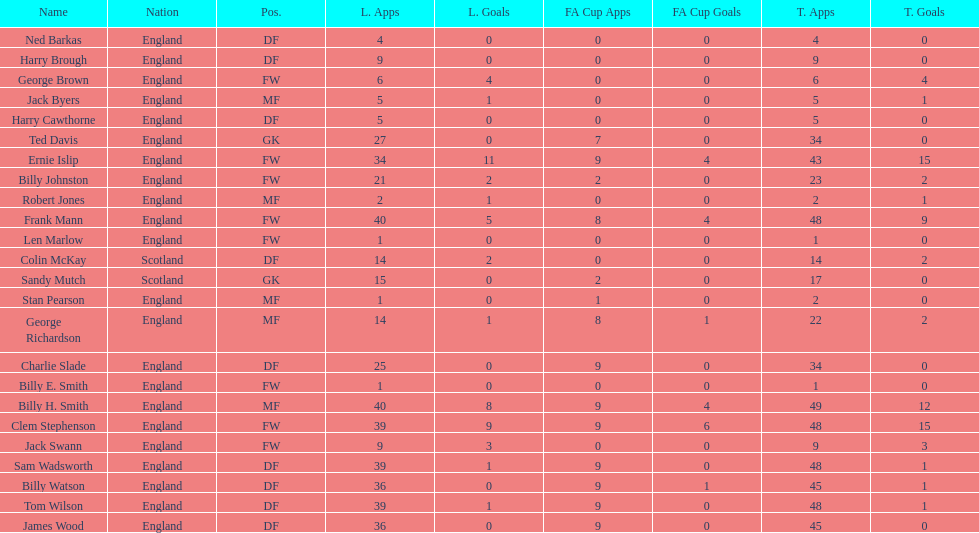Which name appears first in the list? Ned Barkas. I'm looking to parse the entire table for insights. Could you assist me with that? {'header': ['Name', 'Nation', 'Pos.', 'L. Apps', 'L. Goals', 'FA Cup Apps', 'FA Cup Goals', 'T. Apps', 'T. Goals'], 'rows': [['Ned Barkas', 'England', 'DF', '4', '0', '0', '0', '4', '0'], ['Harry Brough', 'England', 'DF', '9', '0', '0', '0', '9', '0'], ['George Brown', 'England', 'FW', '6', '4', '0', '0', '6', '4'], ['Jack Byers', 'England', 'MF', '5', '1', '0', '0', '5', '1'], ['Harry Cawthorne', 'England', 'DF', '5', '0', '0', '0', '5', '0'], ['Ted Davis', 'England', 'GK', '27', '0', '7', '0', '34', '0'], ['Ernie Islip', 'England', 'FW', '34', '11', '9', '4', '43', '15'], ['Billy Johnston', 'England', 'FW', '21', '2', '2', '0', '23', '2'], ['Robert Jones', 'England', 'MF', '2', '1', '0', '0', '2', '1'], ['Frank Mann', 'England', 'FW', '40', '5', '8', '4', '48', '9'], ['Len Marlow', 'England', 'FW', '1', '0', '0', '0', '1', '0'], ['Colin McKay', 'Scotland', 'DF', '14', '2', '0', '0', '14', '2'], ['Sandy Mutch', 'Scotland', 'GK', '15', '0', '2', '0', '17', '0'], ['Stan Pearson', 'England', 'MF', '1', '0', '1', '0', '2', '0'], ['George Richardson', 'England', 'MF', '14', '1', '8', '1', '22', '2'], ['Charlie Slade', 'England', 'DF', '25', '0', '9', '0', '34', '0'], ['Billy E. Smith', 'England', 'FW', '1', '0', '0', '0', '1', '0'], ['Billy H. Smith', 'England', 'MF', '40', '8', '9', '4', '49', '12'], ['Clem Stephenson', 'England', 'FW', '39', '9', '9', '6', '48', '15'], ['Jack Swann', 'England', 'FW', '9', '3', '0', '0', '9', '3'], ['Sam Wadsworth', 'England', 'DF', '39', '1', '9', '0', '48', '1'], ['Billy Watson', 'England', 'DF', '36', '0', '9', '1', '45', '1'], ['Tom Wilson', 'England', 'DF', '39', '1', '9', '0', '48', '1'], ['James Wood', 'England', 'DF', '36', '0', '9', '0', '45', '0']]} 